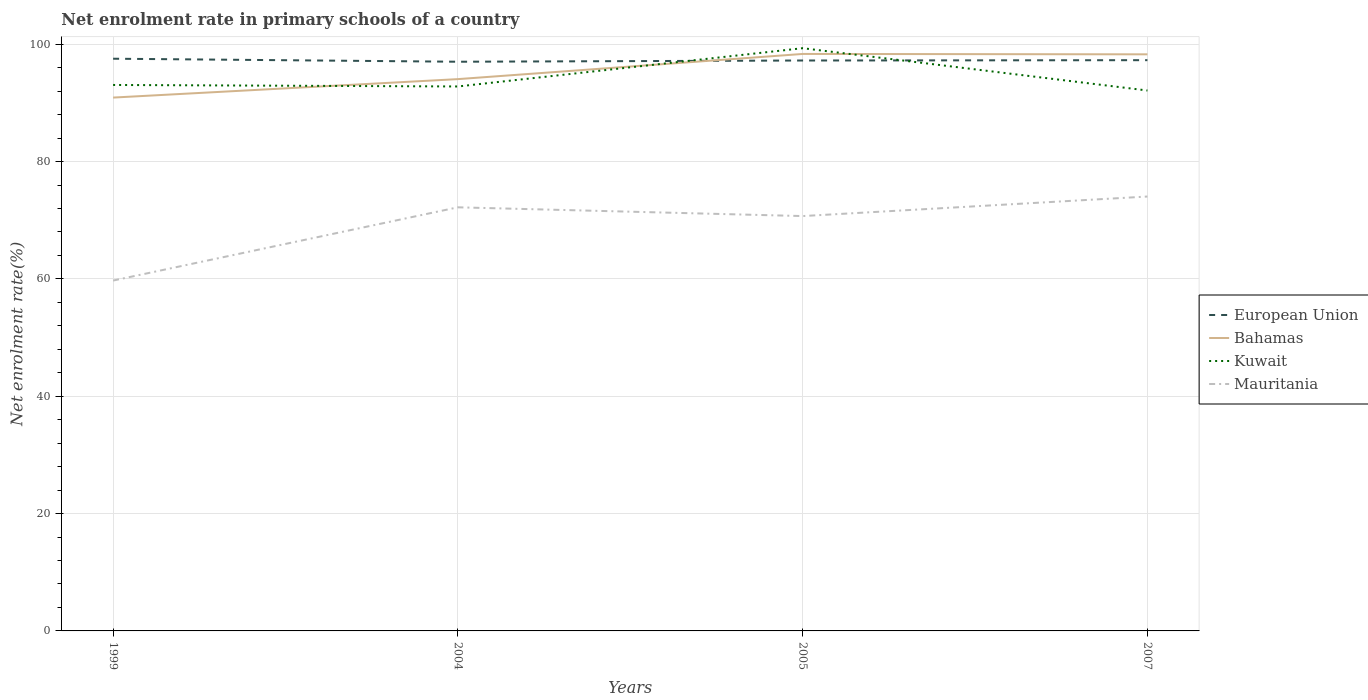Is the number of lines equal to the number of legend labels?
Your response must be concise. Yes. Across all years, what is the maximum net enrolment rate in primary schools in Mauritania?
Provide a succinct answer. 59.71. What is the total net enrolment rate in primary schools in Kuwait in the graph?
Provide a short and direct response. -6.27. What is the difference between the highest and the second highest net enrolment rate in primary schools in Kuwait?
Provide a short and direct response. 7.21. How many years are there in the graph?
Offer a terse response. 4. What is the difference between two consecutive major ticks on the Y-axis?
Provide a succinct answer. 20. Are the values on the major ticks of Y-axis written in scientific E-notation?
Provide a short and direct response. No. Does the graph contain any zero values?
Ensure brevity in your answer.  No. Does the graph contain grids?
Your answer should be very brief. Yes. Where does the legend appear in the graph?
Ensure brevity in your answer.  Center right. What is the title of the graph?
Your response must be concise. Net enrolment rate in primary schools of a country. Does "Cyprus" appear as one of the legend labels in the graph?
Keep it short and to the point. No. What is the label or title of the Y-axis?
Ensure brevity in your answer.  Net enrolment rate(%). What is the Net enrolment rate(%) in European Union in 1999?
Provide a succinct answer. 97.52. What is the Net enrolment rate(%) of Bahamas in 1999?
Your answer should be compact. 90.9. What is the Net enrolment rate(%) in Kuwait in 1999?
Offer a very short reply. 93.05. What is the Net enrolment rate(%) of Mauritania in 1999?
Offer a terse response. 59.71. What is the Net enrolment rate(%) of European Union in 2004?
Offer a terse response. 97.01. What is the Net enrolment rate(%) in Bahamas in 2004?
Keep it short and to the point. 94.05. What is the Net enrolment rate(%) in Kuwait in 2004?
Your response must be concise. 92.79. What is the Net enrolment rate(%) of Mauritania in 2004?
Your answer should be very brief. 72.2. What is the Net enrolment rate(%) of European Union in 2005?
Keep it short and to the point. 97.22. What is the Net enrolment rate(%) in Bahamas in 2005?
Ensure brevity in your answer.  98.34. What is the Net enrolment rate(%) in Kuwait in 2005?
Offer a very short reply. 99.32. What is the Net enrolment rate(%) in Mauritania in 2005?
Keep it short and to the point. 70.71. What is the Net enrolment rate(%) of European Union in 2007?
Offer a very short reply. 97.28. What is the Net enrolment rate(%) of Bahamas in 2007?
Offer a terse response. 98.27. What is the Net enrolment rate(%) of Kuwait in 2007?
Offer a very short reply. 92.11. What is the Net enrolment rate(%) of Mauritania in 2007?
Make the answer very short. 74.04. Across all years, what is the maximum Net enrolment rate(%) of European Union?
Give a very brief answer. 97.52. Across all years, what is the maximum Net enrolment rate(%) in Bahamas?
Ensure brevity in your answer.  98.34. Across all years, what is the maximum Net enrolment rate(%) in Kuwait?
Your response must be concise. 99.32. Across all years, what is the maximum Net enrolment rate(%) in Mauritania?
Provide a short and direct response. 74.04. Across all years, what is the minimum Net enrolment rate(%) of European Union?
Ensure brevity in your answer.  97.01. Across all years, what is the minimum Net enrolment rate(%) in Bahamas?
Keep it short and to the point. 90.9. Across all years, what is the minimum Net enrolment rate(%) in Kuwait?
Offer a terse response. 92.11. Across all years, what is the minimum Net enrolment rate(%) in Mauritania?
Provide a short and direct response. 59.71. What is the total Net enrolment rate(%) in European Union in the graph?
Give a very brief answer. 389.03. What is the total Net enrolment rate(%) of Bahamas in the graph?
Offer a terse response. 381.56. What is the total Net enrolment rate(%) in Kuwait in the graph?
Keep it short and to the point. 377.27. What is the total Net enrolment rate(%) of Mauritania in the graph?
Offer a very short reply. 276.66. What is the difference between the Net enrolment rate(%) in European Union in 1999 and that in 2004?
Your answer should be very brief. 0.51. What is the difference between the Net enrolment rate(%) in Bahamas in 1999 and that in 2004?
Offer a terse response. -3.15. What is the difference between the Net enrolment rate(%) in Kuwait in 1999 and that in 2004?
Your answer should be compact. 0.26. What is the difference between the Net enrolment rate(%) in Mauritania in 1999 and that in 2004?
Provide a succinct answer. -12.48. What is the difference between the Net enrolment rate(%) in European Union in 1999 and that in 2005?
Ensure brevity in your answer.  0.31. What is the difference between the Net enrolment rate(%) of Bahamas in 1999 and that in 2005?
Your answer should be very brief. -7.44. What is the difference between the Net enrolment rate(%) in Kuwait in 1999 and that in 2005?
Give a very brief answer. -6.27. What is the difference between the Net enrolment rate(%) in Mauritania in 1999 and that in 2005?
Provide a short and direct response. -10.99. What is the difference between the Net enrolment rate(%) in European Union in 1999 and that in 2007?
Give a very brief answer. 0.25. What is the difference between the Net enrolment rate(%) of Bahamas in 1999 and that in 2007?
Make the answer very short. -7.37. What is the difference between the Net enrolment rate(%) of Kuwait in 1999 and that in 2007?
Offer a very short reply. 0.95. What is the difference between the Net enrolment rate(%) of Mauritania in 1999 and that in 2007?
Ensure brevity in your answer.  -14.32. What is the difference between the Net enrolment rate(%) of European Union in 2004 and that in 2005?
Your answer should be very brief. -0.21. What is the difference between the Net enrolment rate(%) in Bahamas in 2004 and that in 2005?
Provide a short and direct response. -4.29. What is the difference between the Net enrolment rate(%) in Kuwait in 2004 and that in 2005?
Ensure brevity in your answer.  -6.52. What is the difference between the Net enrolment rate(%) in Mauritania in 2004 and that in 2005?
Keep it short and to the point. 1.49. What is the difference between the Net enrolment rate(%) of European Union in 2004 and that in 2007?
Provide a succinct answer. -0.27. What is the difference between the Net enrolment rate(%) in Bahamas in 2004 and that in 2007?
Provide a succinct answer. -4.23. What is the difference between the Net enrolment rate(%) of Kuwait in 2004 and that in 2007?
Ensure brevity in your answer.  0.69. What is the difference between the Net enrolment rate(%) of Mauritania in 2004 and that in 2007?
Provide a short and direct response. -1.84. What is the difference between the Net enrolment rate(%) of European Union in 2005 and that in 2007?
Make the answer very short. -0.06. What is the difference between the Net enrolment rate(%) in Bahamas in 2005 and that in 2007?
Provide a succinct answer. 0.06. What is the difference between the Net enrolment rate(%) of Kuwait in 2005 and that in 2007?
Your response must be concise. 7.21. What is the difference between the Net enrolment rate(%) in Mauritania in 2005 and that in 2007?
Ensure brevity in your answer.  -3.33. What is the difference between the Net enrolment rate(%) of European Union in 1999 and the Net enrolment rate(%) of Bahamas in 2004?
Ensure brevity in your answer.  3.48. What is the difference between the Net enrolment rate(%) of European Union in 1999 and the Net enrolment rate(%) of Kuwait in 2004?
Keep it short and to the point. 4.73. What is the difference between the Net enrolment rate(%) in European Union in 1999 and the Net enrolment rate(%) in Mauritania in 2004?
Offer a terse response. 25.33. What is the difference between the Net enrolment rate(%) of Bahamas in 1999 and the Net enrolment rate(%) of Kuwait in 2004?
Keep it short and to the point. -1.89. What is the difference between the Net enrolment rate(%) in Bahamas in 1999 and the Net enrolment rate(%) in Mauritania in 2004?
Your answer should be very brief. 18.7. What is the difference between the Net enrolment rate(%) of Kuwait in 1999 and the Net enrolment rate(%) of Mauritania in 2004?
Keep it short and to the point. 20.85. What is the difference between the Net enrolment rate(%) of European Union in 1999 and the Net enrolment rate(%) of Bahamas in 2005?
Your response must be concise. -0.81. What is the difference between the Net enrolment rate(%) of European Union in 1999 and the Net enrolment rate(%) of Kuwait in 2005?
Give a very brief answer. -1.79. What is the difference between the Net enrolment rate(%) in European Union in 1999 and the Net enrolment rate(%) in Mauritania in 2005?
Provide a short and direct response. 26.82. What is the difference between the Net enrolment rate(%) in Bahamas in 1999 and the Net enrolment rate(%) in Kuwait in 2005?
Your answer should be very brief. -8.42. What is the difference between the Net enrolment rate(%) of Bahamas in 1999 and the Net enrolment rate(%) of Mauritania in 2005?
Your answer should be compact. 20.19. What is the difference between the Net enrolment rate(%) in Kuwait in 1999 and the Net enrolment rate(%) in Mauritania in 2005?
Give a very brief answer. 22.34. What is the difference between the Net enrolment rate(%) of European Union in 1999 and the Net enrolment rate(%) of Bahamas in 2007?
Your answer should be very brief. -0.75. What is the difference between the Net enrolment rate(%) of European Union in 1999 and the Net enrolment rate(%) of Kuwait in 2007?
Make the answer very short. 5.42. What is the difference between the Net enrolment rate(%) of European Union in 1999 and the Net enrolment rate(%) of Mauritania in 2007?
Provide a succinct answer. 23.49. What is the difference between the Net enrolment rate(%) in Bahamas in 1999 and the Net enrolment rate(%) in Kuwait in 2007?
Provide a succinct answer. -1.21. What is the difference between the Net enrolment rate(%) of Bahamas in 1999 and the Net enrolment rate(%) of Mauritania in 2007?
Make the answer very short. 16.86. What is the difference between the Net enrolment rate(%) of Kuwait in 1999 and the Net enrolment rate(%) of Mauritania in 2007?
Ensure brevity in your answer.  19.01. What is the difference between the Net enrolment rate(%) of European Union in 2004 and the Net enrolment rate(%) of Bahamas in 2005?
Your answer should be very brief. -1.33. What is the difference between the Net enrolment rate(%) of European Union in 2004 and the Net enrolment rate(%) of Kuwait in 2005?
Provide a short and direct response. -2.31. What is the difference between the Net enrolment rate(%) in European Union in 2004 and the Net enrolment rate(%) in Mauritania in 2005?
Your answer should be very brief. 26.3. What is the difference between the Net enrolment rate(%) of Bahamas in 2004 and the Net enrolment rate(%) of Kuwait in 2005?
Provide a short and direct response. -5.27. What is the difference between the Net enrolment rate(%) in Bahamas in 2004 and the Net enrolment rate(%) in Mauritania in 2005?
Ensure brevity in your answer.  23.34. What is the difference between the Net enrolment rate(%) in Kuwait in 2004 and the Net enrolment rate(%) in Mauritania in 2005?
Your answer should be compact. 22.09. What is the difference between the Net enrolment rate(%) in European Union in 2004 and the Net enrolment rate(%) in Bahamas in 2007?
Give a very brief answer. -1.26. What is the difference between the Net enrolment rate(%) of European Union in 2004 and the Net enrolment rate(%) of Kuwait in 2007?
Offer a terse response. 4.9. What is the difference between the Net enrolment rate(%) in European Union in 2004 and the Net enrolment rate(%) in Mauritania in 2007?
Your response must be concise. 22.97. What is the difference between the Net enrolment rate(%) of Bahamas in 2004 and the Net enrolment rate(%) of Kuwait in 2007?
Provide a short and direct response. 1.94. What is the difference between the Net enrolment rate(%) in Bahamas in 2004 and the Net enrolment rate(%) in Mauritania in 2007?
Keep it short and to the point. 20.01. What is the difference between the Net enrolment rate(%) of Kuwait in 2004 and the Net enrolment rate(%) of Mauritania in 2007?
Give a very brief answer. 18.76. What is the difference between the Net enrolment rate(%) in European Union in 2005 and the Net enrolment rate(%) in Bahamas in 2007?
Ensure brevity in your answer.  -1.05. What is the difference between the Net enrolment rate(%) in European Union in 2005 and the Net enrolment rate(%) in Kuwait in 2007?
Your answer should be very brief. 5.11. What is the difference between the Net enrolment rate(%) of European Union in 2005 and the Net enrolment rate(%) of Mauritania in 2007?
Your answer should be very brief. 23.18. What is the difference between the Net enrolment rate(%) of Bahamas in 2005 and the Net enrolment rate(%) of Kuwait in 2007?
Offer a very short reply. 6.23. What is the difference between the Net enrolment rate(%) in Bahamas in 2005 and the Net enrolment rate(%) in Mauritania in 2007?
Keep it short and to the point. 24.3. What is the difference between the Net enrolment rate(%) in Kuwait in 2005 and the Net enrolment rate(%) in Mauritania in 2007?
Ensure brevity in your answer.  25.28. What is the average Net enrolment rate(%) of European Union per year?
Your answer should be compact. 97.26. What is the average Net enrolment rate(%) of Bahamas per year?
Make the answer very short. 95.39. What is the average Net enrolment rate(%) in Kuwait per year?
Give a very brief answer. 94.32. What is the average Net enrolment rate(%) of Mauritania per year?
Ensure brevity in your answer.  69.16. In the year 1999, what is the difference between the Net enrolment rate(%) in European Union and Net enrolment rate(%) in Bahamas?
Provide a succinct answer. 6.62. In the year 1999, what is the difference between the Net enrolment rate(%) of European Union and Net enrolment rate(%) of Kuwait?
Make the answer very short. 4.47. In the year 1999, what is the difference between the Net enrolment rate(%) of European Union and Net enrolment rate(%) of Mauritania?
Offer a terse response. 37.81. In the year 1999, what is the difference between the Net enrolment rate(%) in Bahamas and Net enrolment rate(%) in Kuwait?
Offer a very short reply. -2.15. In the year 1999, what is the difference between the Net enrolment rate(%) of Bahamas and Net enrolment rate(%) of Mauritania?
Offer a terse response. 31.19. In the year 1999, what is the difference between the Net enrolment rate(%) of Kuwait and Net enrolment rate(%) of Mauritania?
Offer a very short reply. 33.34. In the year 2004, what is the difference between the Net enrolment rate(%) in European Union and Net enrolment rate(%) in Bahamas?
Offer a very short reply. 2.96. In the year 2004, what is the difference between the Net enrolment rate(%) in European Union and Net enrolment rate(%) in Kuwait?
Provide a succinct answer. 4.22. In the year 2004, what is the difference between the Net enrolment rate(%) of European Union and Net enrolment rate(%) of Mauritania?
Your answer should be compact. 24.81. In the year 2004, what is the difference between the Net enrolment rate(%) of Bahamas and Net enrolment rate(%) of Kuwait?
Provide a succinct answer. 1.25. In the year 2004, what is the difference between the Net enrolment rate(%) in Bahamas and Net enrolment rate(%) in Mauritania?
Make the answer very short. 21.85. In the year 2004, what is the difference between the Net enrolment rate(%) in Kuwait and Net enrolment rate(%) in Mauritania?
Give a very brief answer. 20.6. In the year 2005, what is the difference between the Net enrolment rate(%) of European Union and Net enrolment rate(%) of Bahamas?
Provide a short and direct response. -1.12. In the year 2005, what is the difference between the Net enrolment rate(%) of European Union and Net enrolment rate(%) of Kuwait?
Provide a succinct answer. -2.1. In the year 2005, what is the difference between the Net enrolment rate(%) in European Union and Net enrolment rate(%) in Mauritania?
Ensure brevity in your answer.  26.51. In the year 2005, what is the difference between the Net enrolment rate(%) in Bahamas and Net enrolment rate(%) in Kuwait?
Provide a succinct answer. -0.98. In the year 2005, what is the difference between the Net enrolment rate(%) in Bahamas and Net enrolment rate(%) in Mauritania?
Your answer should be very brief. 27.63. In the year 2005, what is the difference between the Net enrolment rate(%) of Kuwait and Net enrolment rate(%) of Mauritania?
Provide a succinct answer. 28.61. In the year 2007, what is the difference between the Net enrolment rate(%) in European Union and Net enrolment rate(%) in Bahamas?
Give a very brief answer. -1. In the year 2007, what is the difference between the Net enrolment rate(%) of European Union and Net enrolment rate(%) of Kuwait?
Provide a succinct answer. 5.17. In the year 2007, what is the difference between the Net enrolment rate(%) in European Union and Net enrolment rate(%) in Mauritania?
Your response must be concise. 23.24. In the year 2007, what is the difference between the Net enrolment rate(%) in Bahamas and Net enrolment rate(%) in Kuwait?
Ensure brevity in your answer.  6.17. In the year 2007, what is the difference between the Net enrolment rate(%) in Bahamas and Net enrolment rate(%) in Mauritania?
Make the answer very short. 24.24. In the year 2007, what is the difference between the Net enrolment rate(%) in Kuwait and Net enrolment rate(%) in Mauritania?
Ensure brevity in your answer.  18.07. What is the ratio of the Net enrolment rate(%) of European Union in 1999 to that in 2004?
Offer a very short reply. 1.01. What is the ratio of the Net enrolment rate(%) of Bahamas in 1999 to that in 2004?
Keep it short and to the point. 0.97. What is the ratio of the Net enrolment rate(%) of Mauritania in 1999 to that in 2004?
Make the answer very short. 0.83. What is the ratio of the Net enrolment rate(%) in European Union in 1999 to that in 2005?
Provide a short and direct response. 1. What is the ratio of the Net enrolment rate(%) in Bahamas in 1999 to that in 2005?
Offer a very short reply. 0.92. What is the ratio of the Net enrolment rate(%) in Kuwait in 1999 to that in 2005?
Provide a short and direct response. 0.94. What is the ratio of the Net enrolment rate(%) of Mauritania in 1999 to that in 2005?
Make the answer very short. 0.84. What is the ratio of the Net enrolment rate(%) in European Union in 1999 to that in 2007?
Keep it short and to the point. 1. What is the ratio of the Net enrolment rate(%) in Bahamas in 1999 to that in 2007?
Keep it short and to the point. 0.93. What is the ratio of the Net enrolment rate(%) of Kuwait in 1999 to that in 2007?
Make the answer very short. 1.01. What is the ratio of the Net enrolment rate(%) in Mauritania in 1999 to that in 2007?
Keep it short and to the point. 0.81. What is the ratio of the Net enrolment rate(%) of Bahamas in 2004 to that in 2005?
Ensure brevity in your answer.  0.96. What is the ratio of the Net enrolment rate(%) in Kuwait in 2004 to that in 2005?
Ensure brevity in your answer.  0.93. What is the ratio of the Net enrolment rate(%) in Mauritania in 2004 to that in 2005?
Your answer should be compact. 1.02. What is the ratio of the Net enrolment rate(%) of European Union in 2004 to that in 2007?
Your answer should be compact. 1. What is the ratio of the Net enrolment rate(%) in Bahamas in 2004 to that in 2007?
Your response must be concise. 0.96. What is the ratio of the Net enrolment rate(%) in Kuwait in 2004 to that in 2007?
Offer a very short reply. 1.01. What is the ratio of the Net enrolment rate(%) of Mauritania in 2004 to that in 2007?
Provide a succinct answer. 0.98. What is the ratio of the Net enrolment rate(%) in European Union in 2005 to that in 2007?
Your answer should be very brief. 1. What is the ratio of the Net enrolment rate(%) in Bahamas in 2005 to that in 2007?
Offer a very short reply. 1. What is the ratio of the Net enrolment rate(%) in Kuwait in 2005 to that in 2007?
Your answer should be compact. 1.08. What is the ratio of the Net enrolment rate(%) of Mauritania in 2005 to that in 2007?
Your answer should be very brief. 0.95. What is the difference between the highest and the second highest Net enrolment rate(%) of European Union?
Your answer should be very brief. 0.25. What is the difference between the highest and the second highest Net enrolment rate(%) of Bahamas?
Your answer should be very brief. 0.06. What is the difference between the highest and the second highest Net enrolment rate(%) of Kuwait?
Provide a short and direct response. 6.27. What is the difference between the highest and the second highest Net enrolment rate(%) in Mauritania?
Make the answer very short. 1.84. What is the difference between the highest and the lowest Net enrolment rate(%) of European Union?
Your response must be concise. 0.51. What is the difference between the highest and the lowest Net enrolment rate(%) of Bahamas?
Your response must be concise. 7.44. What is the difference between the highest and the lowest Net enrolment rate(%) in Kuwait?
Your response must be concise. 7.21. What is the difference between the highest and the lowest Net enrolment rate(%) in Mauritania?
Offer a very short reply. 14.32. 